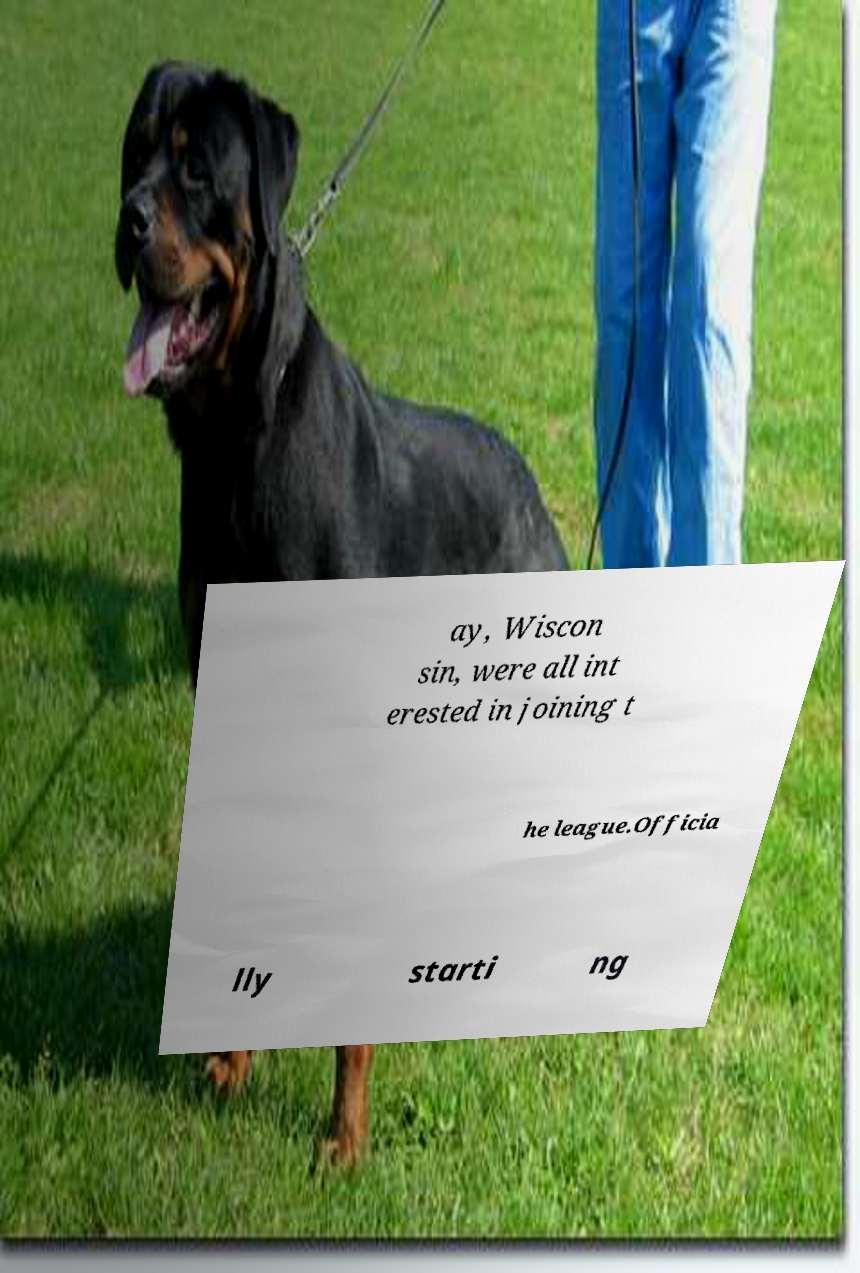What messages or text are displayed in this image? I need them in a readable, typed format. ay, Wiscon sin, were all int erested in joining t he league.Officia lly starti ng 